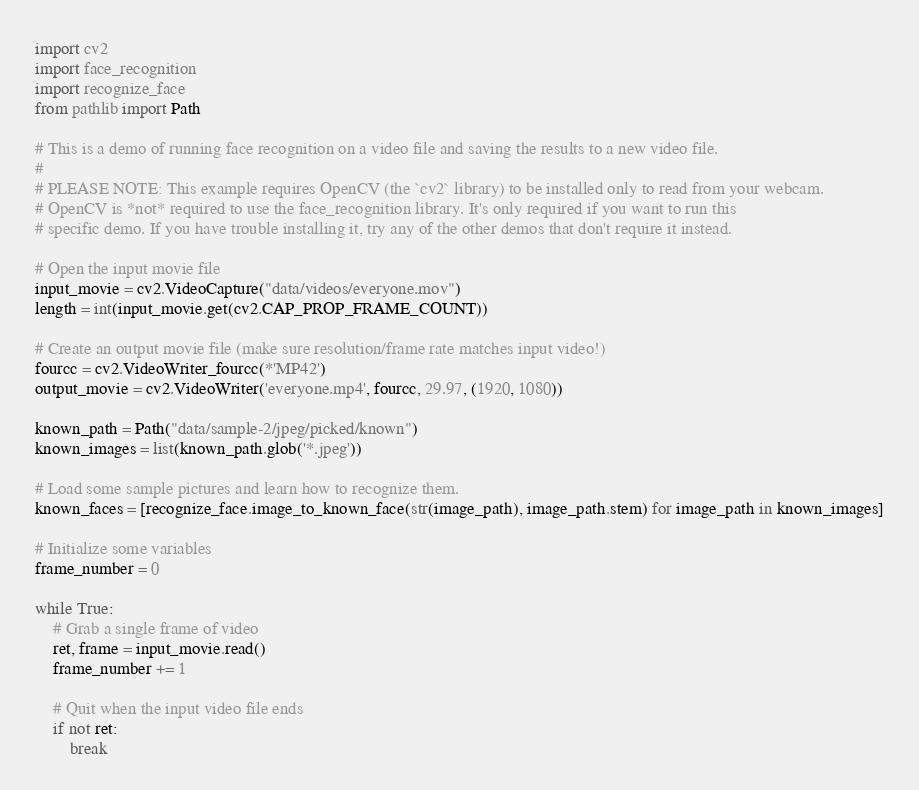Convert code to text. <code><loc_0><loc_0><loc_500><loc_500><_Python_>import cv2
import face_recognition
import recognize_face
from pathlib import Path

# This is a demo of running face recognition on a video file and saving the results to a new video file.
#
# PLEASE NOTE: This example requires OpenCV (the `cv2` library) to be installed only to read from your webcam.
# OpenCV is *not* required to use the face_recognition library. It's only required if you want to run this
# specific demo. If you have trouble installing it, try any of the other demos that don't require it instead.

# Open the input movie file
input_movie = cv2.VideoCapture("data/videos/everyone.mov")
length = int(input_movie.get(cv2.CAP_PROP_FRAME_COUNT))

# Create an output movie file (make sure resolution/frame rate matches input video!)
fourcc = cv2.VideoWriter_fourcc(*'MP42')
output_movie = cv2.VideoWriter('everyone.mp4', fourcc, 29.97, (1920, 1080))

known_path = Path("data/sample-2/jpeg/picked/known")
known_images = list(known_path.glob('*.jpeg'))

# Load some sample pictures and learn how to recognize them.
known_faces = [recognize_face.image_to_known_face(str(image_path), image_path.stem) for image_path in known_images]

# Initialize some variables
frame_number = 0

while True:
    # Grab a single frame of video
    ret, frame = input_movie.read()
    frame_number += 1

    # Quit when the input video file ends
    if not ret:
        break
</code> 